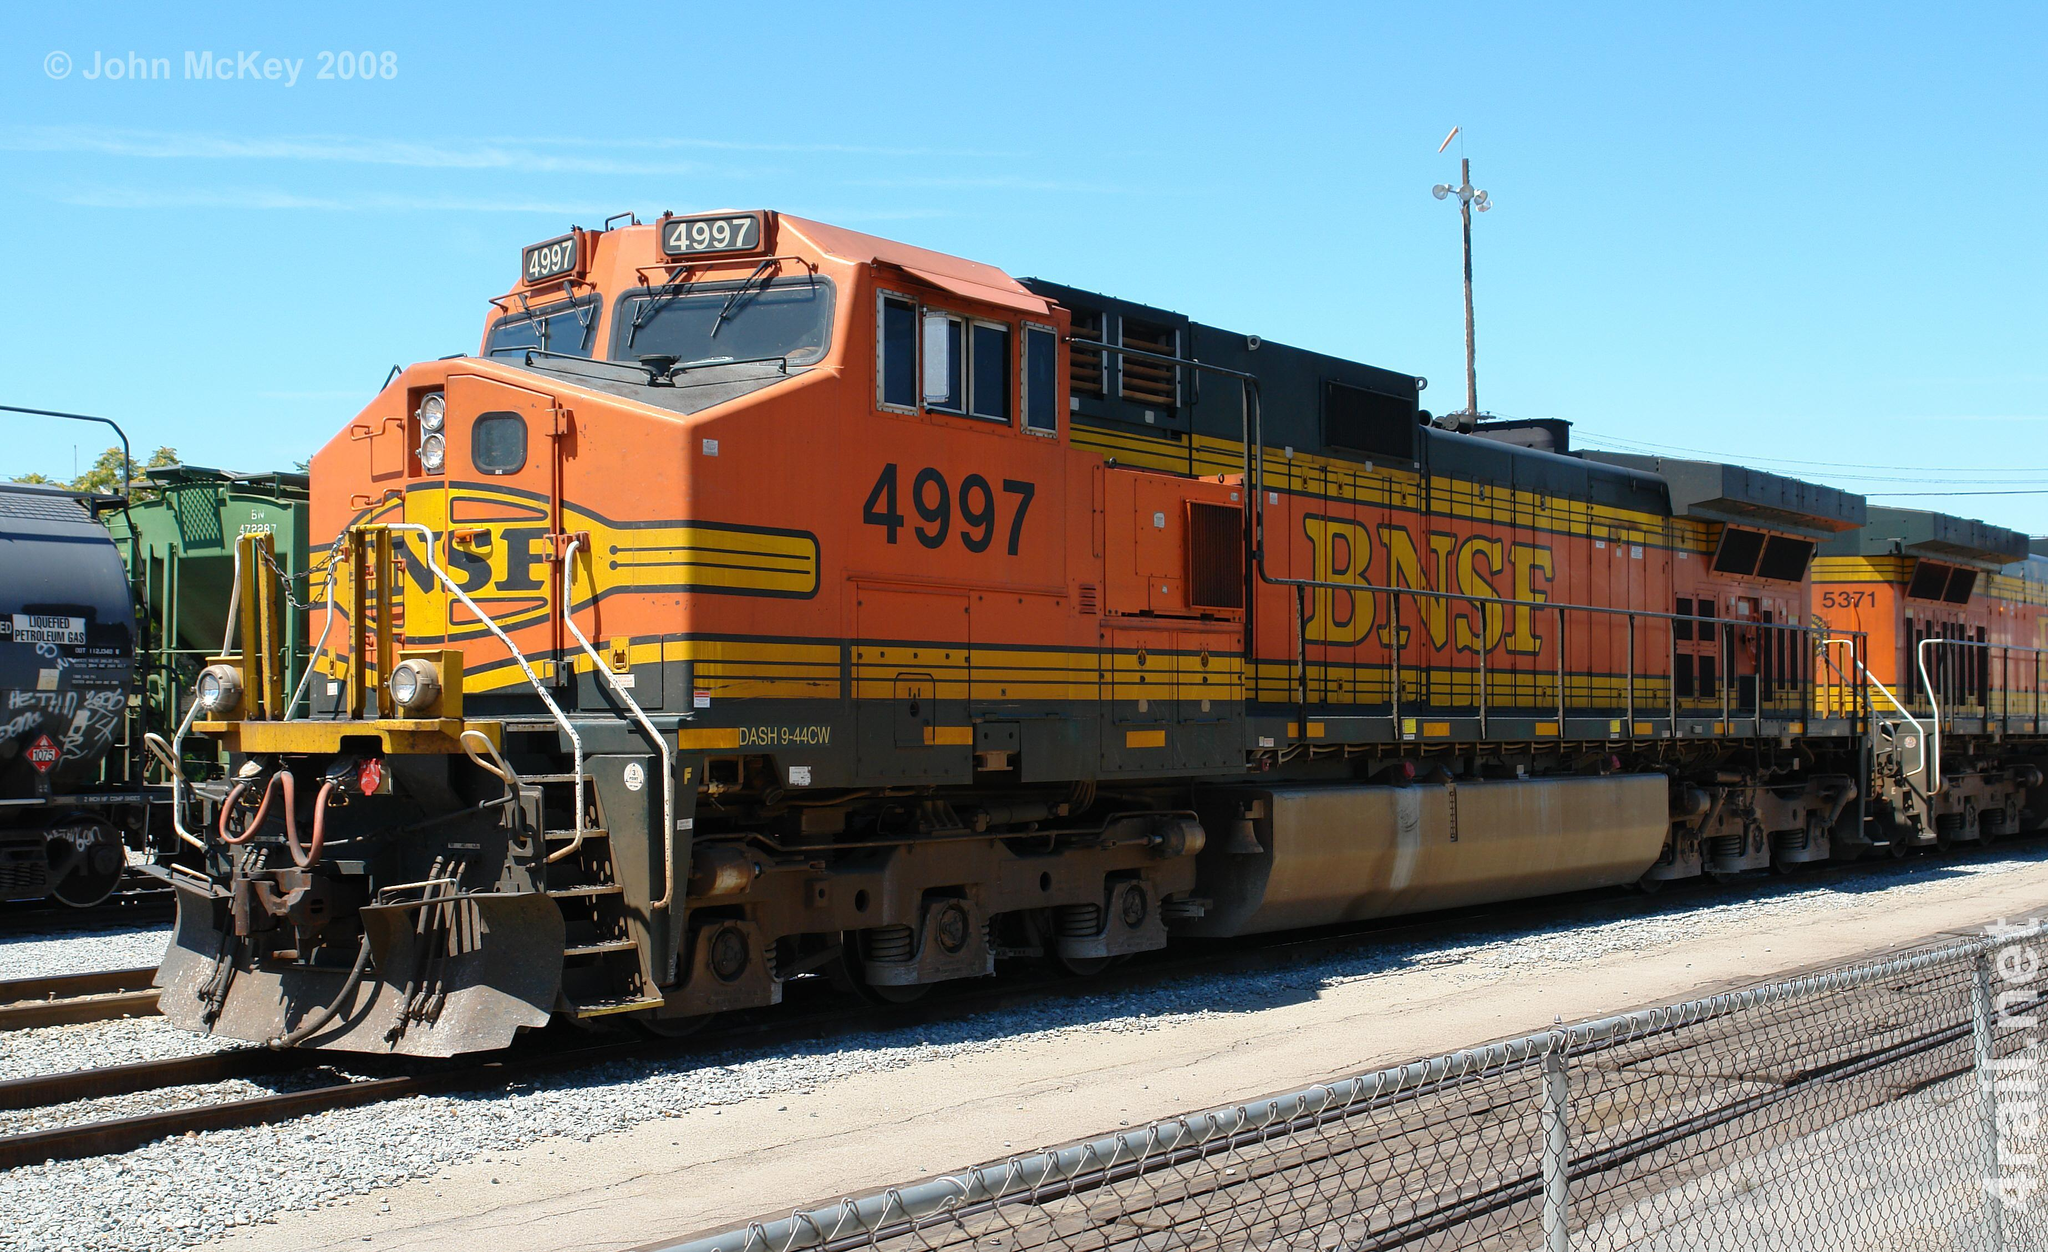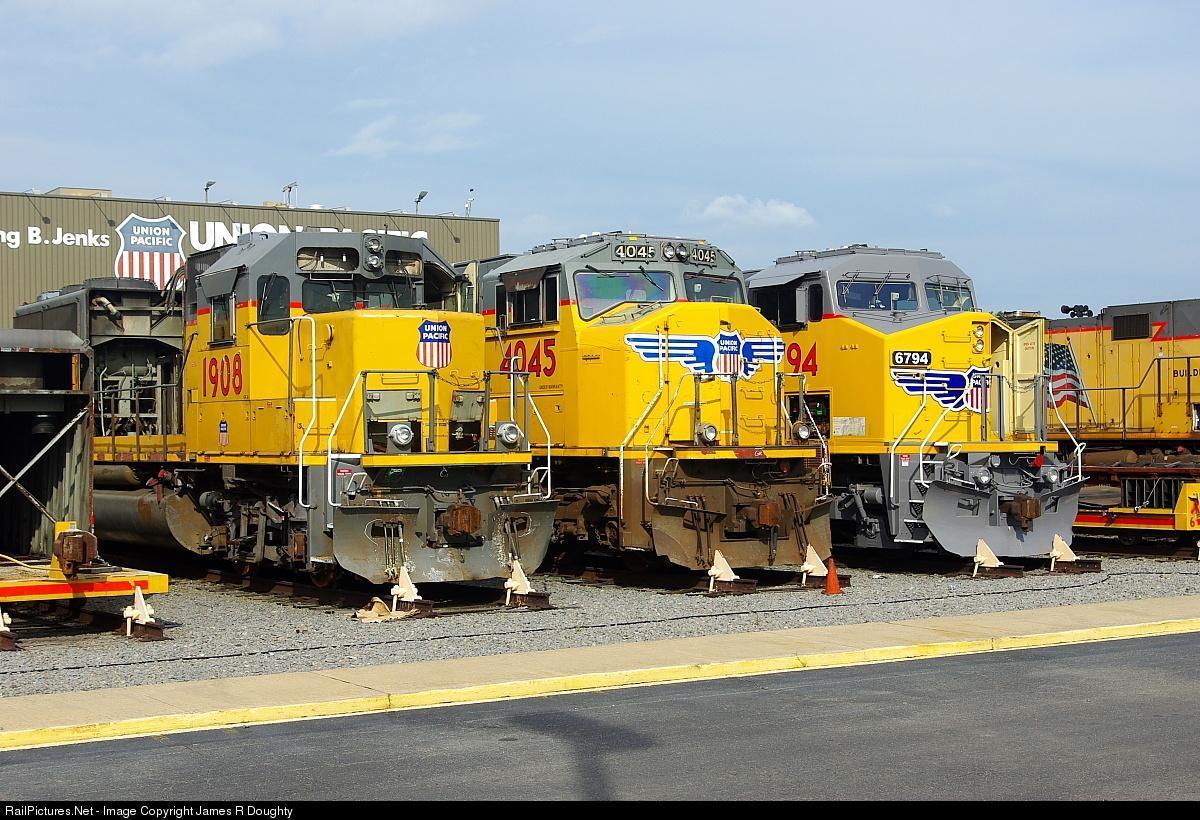The first image is the image on the left, the second image is the image on the right. Considering the images on both sides, is "more then two train cars are being shown in the right side image" valid? Answer yes or no. Yes. The first image is the image on the left, the second image is the image on the right. For the images displayed, is the sentence "There is 1 train on a track facing right in the right image." factually correct? Answer yes or no. No. 